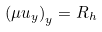Convert formula to latex. <formula><loc_0><loc_0><loc_500><loc_500>\left ( \mu u _ { y } \right ) _ { y } = R _ { h }</formula> 